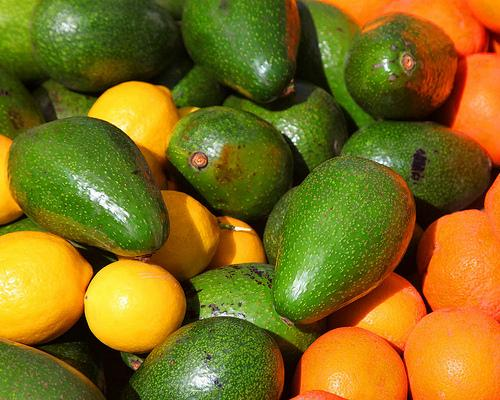Which fruit has the largest and the smallest size in the picture? The largest fruit is an avocado, and the smallest fruit is a lemon. Express the overall sentiment and atmosphere of the image. The image has a lively and fresh atmosphere due to the colorful arrangement of fruits. Identify the types of fruit in the image and how many of each are there? There are 4 avocados, 3 lemons, and 3 oranges in the image. What color are the different fruits in the image? The avocados are green, the lemons are yellow, and the oranges are orange. How many avocados have visible stem marks? There are 2 avocados with visible stem marks. Give a count of the fruits that have imperfections or blemishes. There are 2 avocados, 2 lemons, and 1 orange with imperfections or blemishes. Assess the quality of the image based on its clarity, sharpness, and lighting. The image has good quality with clear details, sharp edges, and balanced lighting on the fruits. It is interesting to notice that there's a large pink watermelon in the center of the image. Can you spot the black seeds on this pink watermelon? This instruction is misleading because it introduces a non-existent object (a pink watermelon) which is not in the list of objects present in the image. It uses a declarative sentence to emphasize the existence of this object and then an interrogative sentence to ask the user to spot another non-existent feature (black seeds) on the watermelon. On the right side of the image, you will find a blue grapefruit with a stripe of green color running through its middle. What is the width and height of this unusual blue grapefruit? This instruction is misleading because it describes a non-existent object (a blue grapefruit) that is not in the list of objects present in the image. Furthermore, it uses both declarative and interrogative sentences, conveying a sense of certainty that this object exists and then asking the user to provide measurements for it, which would not be possible. Examine the bottom right corner of the image and locate a solitary red apple with a shiny surface. What is the ratio of the apple's width to its height? This instruction is misleading because it describes a non-existent object (a red apple) which is not in the list of objects present in the image. It uses a declarative sentence to instruct the user to examine a specific part of the image and then an interrogative sentence to ask the user to find the ratio of the apple's dimensions, which would not be possible as the apple does not exist. Please find the cluster of green grapes hiding behind the avocados on the left side of the image. How many grapes are in this cluster, and what is the typical size of each grape? This instruction is misleading because it introduces a non-existent object (a cluster of green grapes) which is not in the list of objects present in the image. It uses an interrogative sentence to ask the user to count the number of grapes, and another interrogative sentence to find the typical size of each grape, both of which would not be possible since the grapes do not exist. Could you please look for a small purple pineapple in the top left corner? It seems to have an unusual sprinkling of red dots on it. This instruction is misleading because it introduces a non-existent object (a purple pineapple) which is not in the list of objects present in the image. Moreover, it uses an interrogative sentence, asking the user to look for this pineapple, which would not be found in the image. Search for a uniquely shaped green kiwi next to the lemons towards the middle of the image. What is the height of this green kiwi, and can you describe the pattern of its fuzzy skin? This instruction is misleading because it introduces a non-existent object (a green kiwi) which is not in the list of objects present in the image. It uses an interrogative sentence to ask the user to describe the height and the pattern of its fuzzy skin, which would not be possible since the kiwi does not exist. 